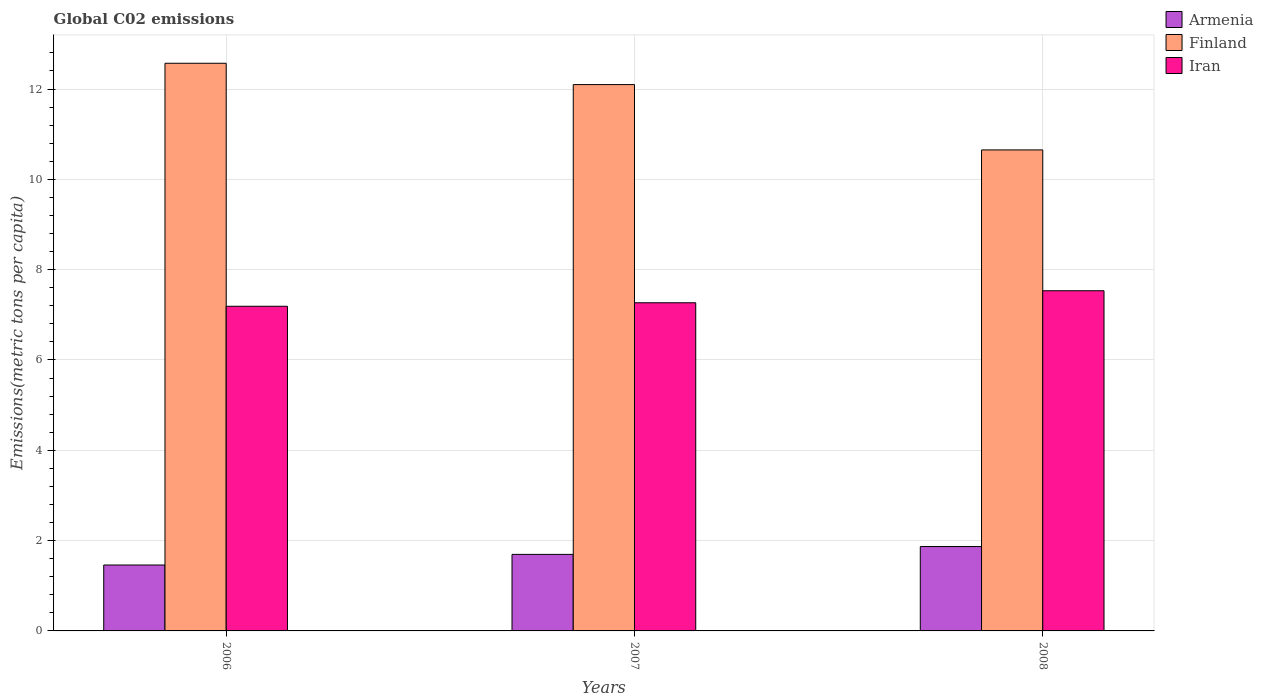How many different coloured bars are there?
Make the answer very short. 3. Are the number of bars on each tick of the X-axis equal?
Provide a succinct answer. Yes. In how many cases, is the number of bars for a given year not equal to the number of legend labels?
Offer a terse response. 0. What is the amount of CO2 emitted in in Armenia in 2006?
Offer a very short reply. 1.46. Across all years, what is the maximum amount of CO2 emitted in in Finland?
Offer a terse response. 12.57. Across all years, what is the minimum amount of CO2 emitted in in Finland?
Your response must be concise. 10.65. In which year was the amount of CO2 emitted in in Armenia maximum?
Make the answer very short. 2008. In which year was the amount of CO2 emitted in in Armenia minimum?
Provide a succinct answer. 2006. What is the total amount of CO2 emitted in in Finland in the graph?
Keep it short and to the point. 35.32. What is the difference between the amount of CO2 emitted in in Armenia in 2006 and that in 2008?
Make the answer very short. -0.41. What is the difference between the amount of CO2 emitted in in Armenia in 2008 and the amount of CO2 emitted in in Iran in 2007?
Provide a succinct answer. -5.4. What is the average amount of CO2 emitted in in Iran per year?
Your response must be concise. 7.33. In the year 2008, what is the difference between the amount of CO2 emitted in in Iran and amount of CO2 emitted in in Armenia?
Ensure brevity in your answer.  5.66. What is the ratio of the amount of CO2 emitted in in Armenia in 2006 to that in 2008?
Make the answer very short. 0.78. Is the amount of CO2 emitted in in Armenia in 2006 less than that in 2007?
Offer a very short reply. Yes. Is the difference between the amount of CO2 emitted in in Iran in 2006 and 2007 greater than the difference between the amount of CO2 emitted in in Armenia in 2006 and 2007?
Make the answer very short. Yes. What is the difference between the highest and the second highest amount of CO2 emitted in in Iran?
Your response must be concise. 0.27. What is the difference between the highest and the lowest amount of CO2 emitted in in Iran?
Keep it short and to the point. 0.34. In how many years, is the amount of CO2 emitted in in Finland greater than the average amount of CO2 emitted in in Finland taken over all years?
Offer a very short reply. 2. Is the sum of the amount of CO2 emitted in in Armenia in 2006 and 2008 greater than the maximum amount of CO2 emitted in in Finland across all years?
Keep it short and to the point. No. What does the 1st bar from the left in 2006 represents?
Offer a terse response. Armenia. What does the 3rd bar from the right in 2008 represents?
Provide a short and direct response. Armenia. How many bars are there?
Offer a terse response. 9. Where does the legend appear in the graph?
Provide a short and direct response. Top right. What is the title of the graph?
Your answer should be compact. Global C02 emissions. What is the label or title of the Y-axis?
Offer a very short reply. Emissions(metric tons per capita). What is the Emissions(metric tons per capita) in Armenia in 2006?
Your response must be concise. 1.46. What is the Emissions(metric tons per capita) of Finland in 2006?
Provide a short and direct response. 12.57. What is the Emissions(metric tons per capita) in Iran in 2006?
Provide a succinct answer. 7.19. What is the Emissions(metric tons per capita) in Armenia in 2007?
Ensure brevity in your answer.  1.69. What is the Emissions(metric tons per capita) of Finland in 2007?
Make the answer very short. 12.1. What is the Emissions(metric tons per capita) of Iran in 2007?
Your answer should be very brief. 7.27. What is the Emissions(metric tons per capita) of Armenia in 2008?
Make the answer very short. 1.87. What is the Emissions(metric tons per capita) in Finland in 2008?
Your answer should be compact. 10.65. What is the Emissions(metric tons per capita) of Iran in 2008?
Provide a short and direct response. 7.53. Across all years, what is the maximum Emissions(metric tons per capita) in Armenia?
Provide a short and direct response. 1.87. Across all years, what is the maximum Emissions(metric tons per capita) in Finland?
Your response must be concise. 12.57. Across all years, what is the maximum Emissions(metric tons per capita) of Iran?
Your response must be concise. 7.53. Across all years, what is the minimum Emissions(metric tons per capita) in Armenia?
Provide a short and direct response. 1.46. Across all years, what is the minimum Emissions(metric tons per capita) of Finland?
Your response must be concise. 10.65. Across all years, what is the minimum Emissions(metric tons per capita) in Iran?
Ensure brevity in your answer.  7.19. What is the total Emissions(metric tons per capita) of Armenia in the graph?
Keep it short and to the point. 5.02. What is the total Emissions(metric tons per capita) in Finland in the graph?
Provide a succinct answer. 35.32. What is the total Emissions(metric tons per capita) of Iran in the graph?
Provide a succinct answer. 21.99. What is the difference between the Emissions(metric tons per capita) of Armenia in 2006 and that in 2007?
Provide a short and direct response. -0.24. What is the difference between the Emissions(metric tons per capita) in Finland in 2006 and that in 2007?
Your response must be concise. 0.47. What is the difference between the Emissions(metric tons per capita) of Iran in 2006 and that in 2007?
Keep it short and to the point. -0.08. What is the difference between the Emissions(metric tons per capita) in Armenia in 2006 and that in 2008?
Ensure brevity in your answer.  -0.41. What is the difference between the Emissions(metric tons per capita) of Finland in 2006 and that in 2008?
Offer a very short reply. 1.92. What is the difference between the Emissions(metric tons per capita) in Iran in 2006 and that in 2008?
Provide a short and direct response. -0.34. What is the difference between the Emissions(metric tons per capita) of Armenia in 2007 and that in 2008?
Make the answer very short. -0.17. What is the difference between the Emissions(metric tons per capita) in Finland in 2007 and that in 2008?
Give a very brief answer. 1.45. What is the difference between the Emissions(metric tons per capita) in Iran in 2007 and that in 2008?
Provide a short and direct response. -0.27. What is the difference between the Emissions(metric tons per capita) in Armenia in 2006 and the Emissions(metric tons per capita) in Finland in 2007?
Your response must be concise. -10.64. What is the difference between the Emissions(metric tons per capita) in Armenia in 2006 and the Emissions(metric tons per capita) in Iran in 2007?
Keep it short and to the point. -5.81. What is the difference between the Emissions(metric tons per capita) of Finland in 2006 and the Emissions(metric tons per capita) of Iran in 2007?
Provide a short and direct response. 5.3. What is the difference between the Emissions(metric tons per capita) in Armenia in 2006 and the Emissions(metric tons per capita) in Finland in 2008?
Your answer should be very brief. -9.19. What is the difference between the Emissions(metric tons per capita) of Armenia in 2006 and the Emissions(metric tons per capita) of Iran in 2008?
Ensure brevity in your answer.  -6.07. What is the difference between the Emissions(metric tons per capita) in Finland in 2006 and the Emissions(metric tons per capita) in Iran in 2008?
Make the answer very short. 5.04. What is the difference between the Emissions(metric tons per capita) of Armenia in 2007 and the Emissions(metric tons per capita) of Finland in 2008?
Provide a succinct answer. -8.96. What is the difference between the Emissions(metric tons per capita) in Armenia in 2007 and the Emissions(metric tons per capita) in Iran in 2008?
Ensure brevity in your answer.  -5.84. What is the difference between the Emissions(metric tons per capita) of Finland in 2007 and the Emissions(metric tons per capita) of Iran in 2008?
Give a very brief answer. 4.57. What is the average Emissions(metric tons per capita) in Armenia per year?
Provide a succinct answer. 1.67. What is the average Emissions(metric tons per capita) in Finland per year?
Offer a terse response. 11.77. What is the average Emissions(metric tons per capita) in Iran per year?
Keep it short and to the point. 7.33. In the year 2006, what is the difference between the Emissions(metric tons per capita) in Armenia and Emissions(metric tons per capita) in Finland?
Ensure brevity in your answer.  -11.11. In the year 2006, what is the difference between the Emissions(metric tons per capita) in Armenia and Emissions(metric tons per capita) in Iran?
Provide a succinct answer. -5.73. In the year 2006, what is the difference between the Emissions(metric tons per capita) in Finland and Emissions(metric tons per capita) in Iran?
Provide a succinct answer. 5.38. In the year 2007, what is the difference between the Emissions(metric tons per capita) of Armenia and Emissions(metric tons per capita) of Finland?
Make the answer very short. -10.4. In the year 2007, what is the difference between the Emissions(metric tons per capita) in Armenia and Emissions(metric tons per capita) in Iran?
Make the answer very short. -5.57. In the year 2007, what is the difference between the Emissions(metric tons per capita) of Finland and Emissions(metric tons per capita) of Iran?
Your answer should be compact. 4.83. In the year 2008, what is the difference between the Emissions(metric tons per capita) of Armenia and Emissions(metric tons per capita) of Finland?
Ensure brevity in your answer.  -8.78. In the year 2008, what is the difference between the Emissions(metric tons per capita) in Armenia and Emissions(metric tons per capita) in Iran?
Ensure brevity in your answer.  -5.66. In the year 2008, what is the difference between the Emissions(metric tons per capita) in Finland and Emissions(metric tons per capita) in Iran?
Your answer should be very brief. 3.12. What is the ratio of the Emissions(metric tons per capita) of Armenia in 2006 to that in 2007?
Your answer should be very brief. 0.86. What is the ratio of the Emissions(metric tons per capita) of Finland in 2006 to that in 2007?
Keep it short and to the point. 1.04. What is the ratio of the Emissions(metric tons per capita) in Iran in 2006 to that in 2007?
Your response must be concise. 0.99. What is the ratio of the Emissions(metric tons per capita) in Armenia in 2006 to that in 2008?
Your response must be concise. 0.78. What is the ratio of the Emissions(metric tons per capita) in Finland in 2006 to that in 2008?
Keep it short and to the point. 1.18. What is the ratio of the Emissions(metric tons per capita) in Iran in 2006 to that in 2008?
Make the answer very short. 0.95. What is the ratio of the Emissions(metric tons per capita) in Armenia in 2007 to that in 2008?
Offer a terse response. 0.91. What is the ratio of the Emissions(metric tons per capita) of Finland in 2007 to that in 2008?
Make the answer very short. 1.14. What is the ratio of the Emissions(metric tons per capita) of Iran in 2007 to that in 2008?
Keep it short and to the point. 0.96. What is the difference between the highest and the second highest Emissions(metric tons per capita) of Armenia?
Provide a short and direct response. 0.17. What is the difference between the highest and the second highest Emissions(metric tons per capita) of Finland?
Keep it short and to the point. 0.47. What is the difference between the highest and the second highest Emissions(metric tons per capita) in Iran?
Make the answer very short. 0.27. What is the difference between the highest and the lowest Emissions(metric tons per capita) in Armenia?
Offer a very short reply. 0.41. What is the difference between the highest and the lowest Emissions(metric tons per capita) in Finland?
Provide a short and direct response. 1.92. What is the difference between the highest and the lowest Emissions(metric tons per capita) in Iran?
Provide a succinct answer. 0.34. 